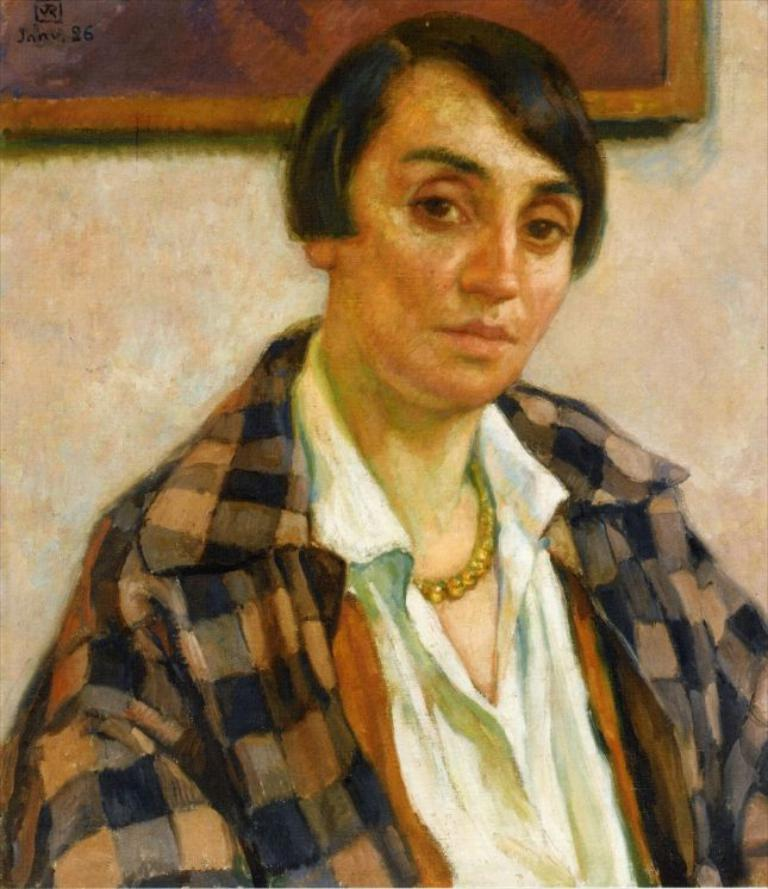What is depicted in the painting in the image? There is a painting of a woman in the image. What surrounds the painting? There is a frame around the painting. Where is the frame located? The frame is on a wall. Are there any snakes visible in the painting? There are no snakes present in the painting or the image. 